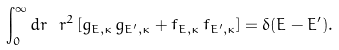Convert formula to latex. <formula><loc_0><loc_0><loc_500><loc_500>\int _ { 0 } ^ { \infty } d r \ r ^ { 2 } \, [ g _ { E , \kappa } \, g _ { E ^ { \prime } , \kappa } + f _ { E , \kappa } \, f _ { E ^ { \prime } , \kappa } ] = \delta ( E - E ^ { \prime } ) .</formula> 